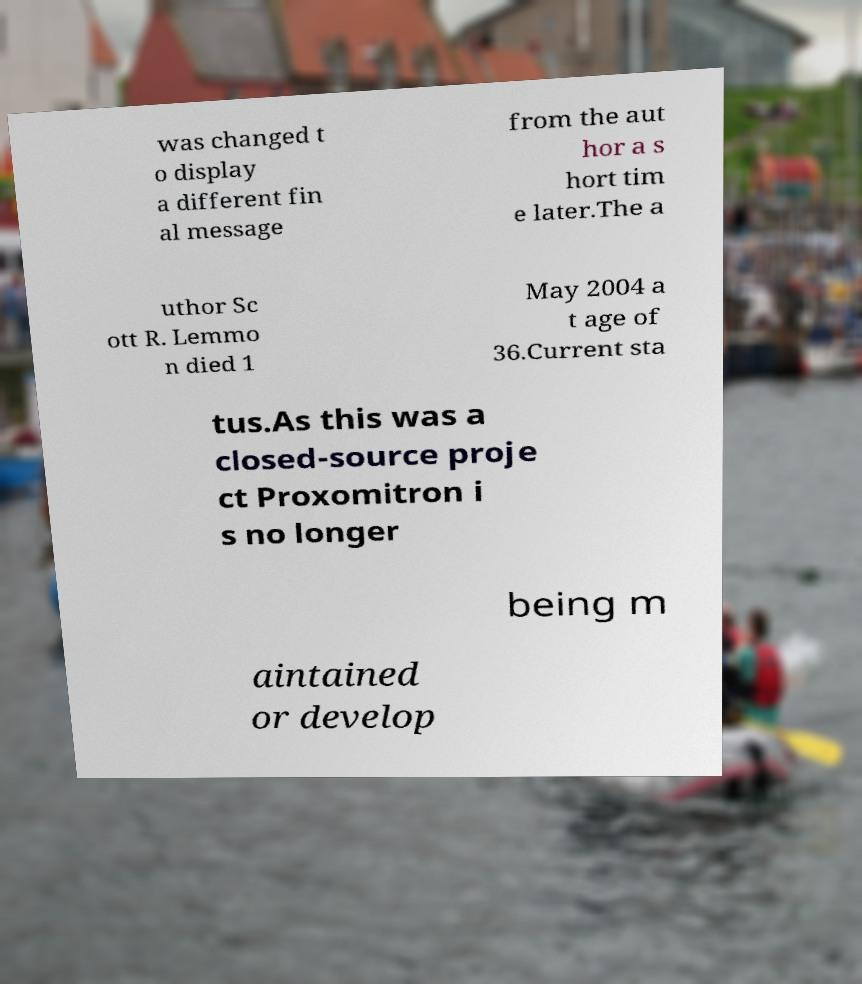Can you accurately transcribe the text from the provided image for me? was changed t o display a different fin al message from the aut hor a s hort tim e later.The a uthor Sc ott R. Lemmo n died 1 May 2004 a t age of 36.Current sta tus.As this was a closed-source proje ct Proxomitron i s no longer being m aintained or develop 